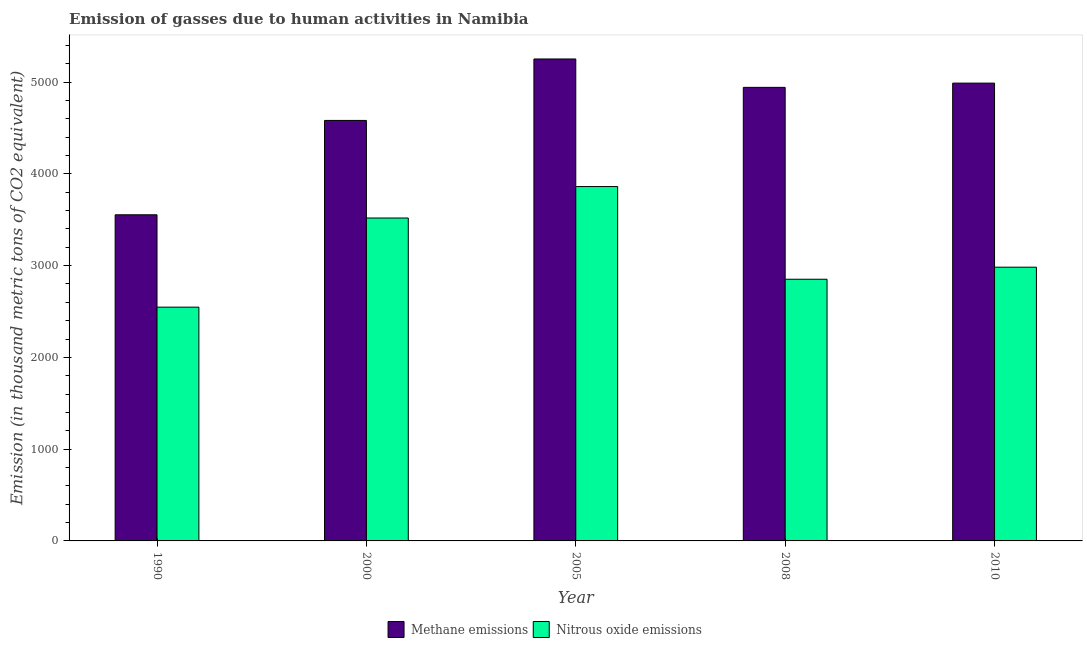Are the number of bars on each tick of the X-axis equal?
Your answer should be compact. Yes. How many bars are there on the 3rd tick from the right?
Give a very brief answer. 2. What is the amount of nitrous oxide emissions in 1990?
Keep it short and to the point. 2547.1. Across all years, what is the maximum amount of nitrous oxide emissions?
Ensure brevity in your answer.  3861.2. Across all years, what is the minimum amount of methane emissions?
Your response must be concise. 3553.5. In which year was the amount of nitrous oxide emissions maximum?
Your response must be concise. 2005. In which year was the amount of nitrous oxide emissions minimum?
Provide a short and direct response. 1990. What is the total amount of methane emissions in the graph?
Provide a short and direct response. 2.33e+04. What is the difference between the amount of nitrous oxide emissions in 2000 and that in 2008?
Your response must be concise. 667.3. What is the difference between the amount of nitrous oxide emissions in 2005 and the amount of methane emissions in 2008?
Keep it short and to the point. 1010. What is the average amount of methane emissions per year?
Make the answer very short. 4663.32. In the year 2010, what is the difference between the amount of nitrous oxide emissions and amount of methane emissions?
Ensure brevity in your answer.  0. In how many years, is the amount of methane emissions greater than 2200 thousand metric tons?
Your answer should be compact. 5. What is the ratio of the amount of nitrous oxide emissions in 1990 to that in 2000?
Your answer should be compact. 0.72. What is the difference between the highest and the second highest amount of nitrous oxide emissions?
Ensure brevity in your answer.  342.7. What is the difference between the highest and the lowest amount of methane emissions?
Ensure brevity in your answer.  1697.8. Is the sum of the amount of methane emissions in 1990 and 2010 greater than the maximum amount of nitrous oxide emissions across all years?
Provide a short and direct response. Yes. What does the 1st bar from the left in 2008 represents?
Offer a terse response. Methane emissions. What does the 1st bar from the right in 2005 represents?
Your answer should be compact. Nitrous oxide emissions. Are all the bars in the graph horizontal?
Provide a short and direct response. No. What is the difference between two consecutive major ticks on the Y-axis?
Give a very brief answer. 1000. Are the values on the major ticks of Y-axis written in scientific E-notation?
Provide a succinct answer. No. Does the graph contain any zero values?
Provide a succinct answer. No. Does the graph contain grids?
Keep it short and to the point. No. How many legend labels are there?
Provide a short and direct response. 2. What is the title of the graph?
Ensure brevity in your answer.  Emission of gasses due to human activities in Namibia. What is the label or title of the X-axis?
Keep it short and to the point. Year. What is the label or title of the Y-axis?
Offer a very short reply. Emission (in thousand metric tons of CO2 equivalent). What is the Emission (in thousand metric tons of CO2 equivalent) in Methane emissions in 1990?
Your response must be concise. 3553.5. What is the Emission (in thousand metric tons of CO2 equivalent) in Nitrous oxide emissions in 1990?
Keep it short and to the point. 2547.1. What is the Emission (in thousand metric tons of CO2 equivalent) in Methane emissions in 2000?
Ensure brevity in your answer.  4581.7. What is the Emission (in thousand metric tons of CO2 equivalent) in Nitrous oxide emissions in 2000?
Offer a very short reply. 3518.5. What is the Emission (in thousand metric tons of CO2 equivalent) in Methane emissions in 2005?
Provide a succinct answer. 5251.3. What is the Emission (in thousand metric tons of CO2 equivalent) in Nitrous oxide emissions in 2005?
Keep it short and to the point. 3861.2. What is the Emission (in thousand metric tons of CO2 equivalent) of Methane emissions in 2008?
Offer a very short reply. 4941.9. What is the Emission (in thousand metric tons of CO2 equivalent) in Nitrous oxide emissions in 2008?
Provide a succinct answer. 2851.2. What is the Emission (in thousand metric tons of CO2 equivalent) in Methane emissions in 2010?
Provide a short and direct response. 4988.2. What is the Emission (in thousand metric tons of CO2 equivalent) in Nitrous oxide emissions in 2010?
Ensure brevity in your answer.  2982.6. Across all years, what is the maximum Emission (in thousand metric tons of CO2 equivalent) in Methane emissions?
Make the answer very short. 5251.3. Across all years, what is the maximum Emission (in thousand metric tons of CO2 equivalent) of Nitrous oxide emissions?
Your answer should be compact. 3861.2. Across all years, what is the minimum Emission (in thousand metric tons of CO2 equivalent) of Methane emissions?
Your answer should be compact. 3553.5. Across all years, what is the minimum Emission (in thousand metric tons of CO2 equivalent) of Nitrous oxide emissions?
Your answer should be compact. 2547.1. What is the total Emission (in thousand metric tons of CO2 equivalent) in Methane emissions in the graph?
Provide a succinct answer. 2.33e+04. What is the total Emission (in thousand metric tons of CO2 equivalent) of Nitrous oxide emissions in the graph?
Keep it short and to the point. 1.58e+04. What is the difference between the Emission (in thousand metric tons of CO2 equivalent) of Methane emissions in 1990 and that in 2000?
Offer a very short reply. -1028.2. What is the difference between the Emission (in thousand metric tons of CO2 equivalent) of Nitrous oxide emissions in 1990 and that in 2000?
Provide a succinct answer. -971.4. What is the difference between the Emission (in thousand metric tons of CO2 equivalent) in Methane emissions in 1990 and that in 2005?
Ensure brevity in your answer.  -1697.8. What is the difference between the Emission (in thousand metric tons of CO2 equivalent) in Nitrous oxide emissions in 1990 and that in 2005?
Offer a very short reply. -1314.1. What is the difference between the Emission (in thousand metric tons of CO2 equivalent) of Methane emissions in 1990 and that in 2008?
Your answer should be very brief. -1388.4. What is the difference between the Emission (in thousand metric tons of CO2 equivalent) of Nitrous oxide emissions in 1990 and that in 2008?
Your response must be concise. -304.1. What is the difference between the Emission (in thousand metric tons of CO2 equivalent) in Methane emissions in 1990 and that in 2010?
Give a very brief answer. -1434.7. What is the difference between the Emission (in thousand metric tons of CO2 equivalent) of Nitrous oxide emissions in 1990 and that in 2010?
Make the answer very short. -435.5. What is the difference between the Emission (in thousand metric tons of CO2 equivalent) in Methane emissions in 2000 and that in 2005?
Your response must be concise. -669.6. What is the difference between the Emission (in thousand metric tons of CO2 equivalent) of Nitrous oxide emissions in 2000 and that in 2005?
Keep it short and to the point. -342.7. What is the difference between the Emission (in thousand metric tons of CO2 equivalent) in Methane emissions in 2000 and that in 2008?
Your answer should be compact. -360.2. What is the difference between the Emission (in thousand metric tons of CO2 equivalent) in Nitrous oxide emissions in 2000 and that in 2008?
Your answer should be very brief. 667.3. What is the difference between the Emission (in thousand metric tons of CO2 equivalent) of Methane emissions in 2000 and that in 2010?
Ensure brevity in your answer.  -406.5. What is the difference between the Emission (in thousand metric tons of CO2 equivalent) of Nitrous oxide emissions in 2000 and that in 2010?
Your response must be concise. 535.9. What is the difference between the Emission (in thousand metric tons of CO2 equivalent) of Methane emissions in 2005 and that in 2008?
Offer a very short reply. 309.4. What is the difference between the Emission (in thousand metric tons of CO2 equivalent) in Nitrous oxide emissions in 2005 and that in 2008?
Offer a very short reply. 1010. What is the difference between the Emission (in thousand metric tons of CO2 equivalent) of Methane emissions in 2005 and that in 2010?
Your answer should be compact. 263.1. What is the difference between the Emission (in thousand metric tons of CO2 equivalent) in Nitrous oxide emissions in 2005 and that in 2010?
Offer a terse response. 878.6. What is the difference between the Emission (in thousand metric tons of CO2 equivalent) of Methane emissions in 2008 and that in 2010?
Provide a short and direct response. -46.3. What is the difference between the Emission (in thousand metric tons of CO2 equivalent) in Nitrous oxide emissions in 2008 and that in 2010?
Give a very brief answer. -131.4. What is the difference between the Emission (in thousand metric tons of CO2 equivalent) in Methane emissions in 1990 and the Emission (in thousand metric tons of CO2 equivalent) in Nitrous oxide emissions in 2000?
Offer a terse response. 35. What is the difference between the Emission (in thousand metric tons of CO2 equivalent) of Methane emissions in 1990 and the Emission (in thousand metric tons of CO2 equivalent) of Nitrous oxide emissions in 2005?
Keep it short and to the point. -307.7. What is the difference between the Emission (in thousand metric tons of CO2 equivalent) of Methane emissions in 1990 and the Emission (in thousand metric tons of CO2 equivalent) of Nitrous oxide emissions in 2008?
Offer a terse response. 702.3. What is the difference between the Emission (in thousand metric tons of CO2 equivalent) in Methane emissions in 1990 and the Emission (in thousand metric tons of CO2 equivalent) in Nitrous oxide emissions in 2010?
Provide a short and direct response. 570.9. What is the difference between the Emission (in thousand metric tons of CO2 equivalent) in Methane emissions in 2000 and the Emission (in thousand metric tons of CO2 equivalent) in Nitrous oxide emissions in 2005?
Make the answer very short. 720.5. What is the difference between the Emission (in thousand metric tons of CO2 equivalent) of Methane emissions in 2000 and the Emission (in thousand metric tons of CO2 equivalent) of Nitrous oxide emissions in 2008?
Provide a short and direct response. 1730.5. What is the difference between the Emission (in thousand metric tons of CO2 equivalent) in Methane emissions in 2000 and the Emission (in thousand metric tons of CO2 equivalent) in Nitrous oxide emissions in 2010?
Your response must be concise. 1599.1. What is the difference between the Emission (in thousand metric tons of CO2 equivalent) in Methane emissions in 2005 and the Emission (in thousand metric tons of CO2 equivalent) in Nitrous oxide emissions in 2008?
Keep it short and to the point. 2400.1. What is the difference between the Emission (in thousand metric tons of CO2 equivalent) of Methane emissions in 2005 and the Emission (in thousand metric tons of CO2 equivalent) of Nitrous oxide emissions in 2010?
Make the answer very short. 2268.7. What is the difference between the Emission (in thousand metric tons of CO2 equivalent) in Methane emissions in 2008 and the Emission (in thousand metric tons of CO2 equivalent) in Nitrous oxide emissions in 2010?
Give a very brief answer. 1959.3. What is the average Emission (in thousand metric tons of CO2 equivalent) in Methane emissions per year?
Offer a very short reply. 4663.32. What is the average Emission (in thousand metric tons of CO2 equivalent) in Nitrous oxide emissions per year?
Provide a succinct answer. 3152.12. In the year 1990, what is the difference between the Emission (in thousand metric tons of CO2 equivalent) of Methane emissions and Emission (in thousand metric tons of CO2 equivalent) of Nitrous oxide emissions?
Your answer should be compact. 1006.4. In the year 2000, what is the difference between the Emission (in thousand metric tons of CO2 equivalent) in Methane emissions and Emission (in thousand metric tons of CO2 equivalent) in Nitrous oxide emissions?
Offer a terse response. 1063.2. In the year 2005, what is the difference between the Emission (in thousand metric tons of CO2 equivalent) in Methane emissions and Emission (in thousand metric tons of CO2 equivalent) in Nitrous oxide emissions?
Provide a short and direct response. 1390.1. In the year 2008, what is the difference between the Emission (in thousand metric tons of CO2 equivalent) of Methane emissions and Emission (in thousand metric tons of CO2 equivalent) of Nitrous oxide emissions?
Offer a terse response. 2090.7. In the year 2010, what is the difference between the Emission (in thousand metric tons of CO2 equivalent) of Methane emissions and Emission (in thousand metric tons of CO2 equivalent) of Nitrous oxide emissions?
Provide a succinct answer. 2005.6. What is the ratio of the Emission (in thousand metric tons of CO2 equivalent) of Methane emissions in 1990 to that in 2000?
Offer a terse response. 0.78. What is the ratio of the Emission (in thousand metric tons of CO2 equivalent) in Nitrous oxide emissions in 1990 to that in 2000?
Your answer should be very brief. 0.72. What is the ratio of the Emission (in thousand metric tons of CO2 equivalent) in Methane emissions in 1990 to that in 2005?
Give a very brief answer. 0.68. What is the ratio of the Emission (in thousand metric tons of CO2 equivalent) of Nitrous oxide emissions in 1990 to that in 2005?
Offer a terse response. 0.66. What is the ratio of the Emission (in thousand metric tons of CO2 equivalent) in Methane emissions in 1990 to that in 2008?
Make the answer very short. 0.72. What is the ratio of the Emission (in thousand metric tons of CO2 equivalent) of Nitrous oxide emissions in 1990 to that in 2008?
Ensure brevity in your answer.  0.89. What is the ratio of the Emission (in thousand metric tons of CO2 equivalent) in Methane emissions in 1990 to that in 2010?
Your response must be concise. 0.71. What is the ratio of the Emission (in thousand metric tons of CO2 equivalent) of Nitrous oxide emissions in 1990 to that in 2010?
Your answer should be very brief. 0.85. What is the ratio of the Emission (in thousand metric tons of CO2 equivalent) of Methane emissions in 2000 to that in 2005?
Provide a short and direct response. 0.87. What is the ratio of the Emission (in thousand metric tons of CO2 equivalent) in Nitrous oxide emissions in 2000 to that in 2005?
Make the answer very short. 0.91. What is the ratio of the Emission (in thousand metric tons of CO2 equivalent) in Methane emissions in 2000 to that in 2008?
Your answer should be very brief. 0.93. What is the ratio of the Emission (in thousand metric tons of CO2 equivalent) in Nitrous oxide emissions in 2000 to that in 2008?
Your answer should be very brief. 1.23. What is the ratio of the Emission (in thousand metric tons of CO2 equivalent) in Methane emissions in 2000 to that in 2010?
Give a very brief answer. 0.92. What is the ratio of the Emission (in thousand metric tons of CO2 equivalent) of Nitrous oxide emissions in 2000 to that in 2010?
Offer a very short reply. 1.18. What is the ratio of the Emission (in thousand metric tons of CO2 equivalent) in Methane emissions in 2005 to that in 2008?
Give a very brief answer. 1.06. What is the ratio of the Emission (in thousand metric tons of CO2 equivalent) of Nitrous oxide emissions in 2005 to that in 2008?
Your answer should be very brief. 1.35. What is the ratio of the Emission (in thousand metric tons of CO2 equivalent) of Methane emissions in 2005 to that in 2010?
Your answer should be very brief. 1.05. What is the ratio of the Emission (in thousand metric tons of CO2 equivalent) in Nitrous oxide emissions in 2005 to that in 2010?
Your answer should be very brief. 1.29. What is the ratio of the Emission (in thousand metric tons of CO2 equivalent) in Methane emissions in 2008 to that in 2010?
Your response must be concise. 0.99. What is the ratio of the Emission (in thousand metric tons of CO2 equivalent) in Nitrous oxide emissions in 2008 to that in 2010?
Your answer should be very brief. 0.96. What is the difference between the highest and the second highest Emission (in thousand metric tons of CO2 equivalent) of Methane emissions?
Keep it short and to the point. 263.1. What is the difference between the highest and the second highest Emission (in thousand metric tons of CO2 equivalent) of Nitrous oxide emissions?
Offer a terse response. 342.7. What is the difference between the highest and the lowest Emission (in thousand metric tons of CO2 equivalent) of Methane emissions?
Give a very brief answer. 1697.8. What is the difference between the highest and the lowest Emission (in thousand metric tons of CO2 equivalent) in Nitrous oxide emissions?
Give a very brief answer. 1314.1. 